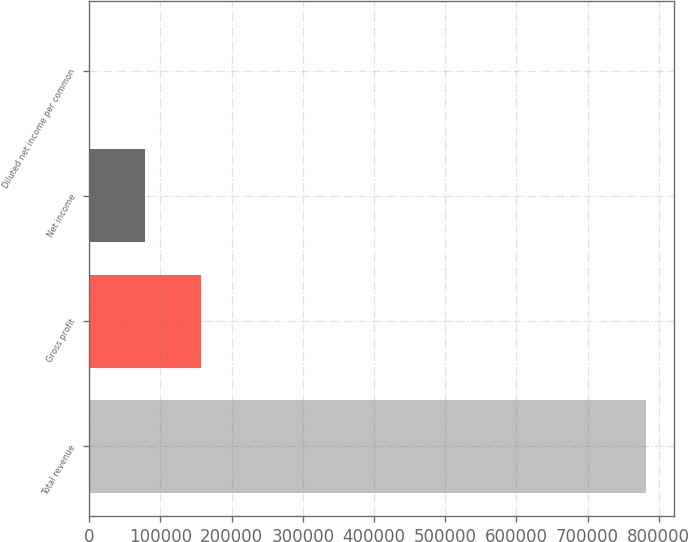Convert chart. <chart><loc_0><loc_0><loc_500><loc_500><bar_chart><fcel>Total revenue<fcel>Gross profit<fcel>Net income<fcel>Diluted net income per common<nl><fcel>782171<fcel>156434<fcel>78217.3<fcel>0.2<nl></chart> 